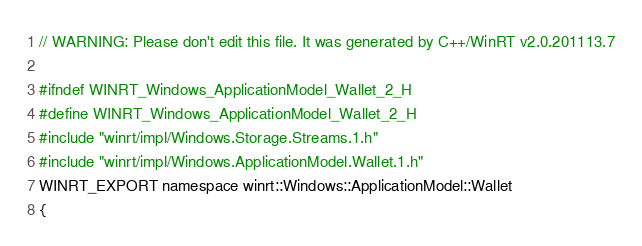<code> <loc_0><loc_0><loc_500><loc_500><_C_>// WARNING: Please don't edit this file. It was generated by C++/WinRT v2.0.201113.7

#ifndef WINRT_Windows_ApplicationModel_Wallet_2_H
#define WINRT_Windows_ApplicationModel_Wallet_2_H
#include "winrt/impl/Windows.Storage.Streams.1.h"
#include "winrt/impl/Windows.ApplicationModel.Wallet.1.h"
WINRT_EXPORT namespace winrt::Windows::ApplicationModel::Wallet
{</code> 